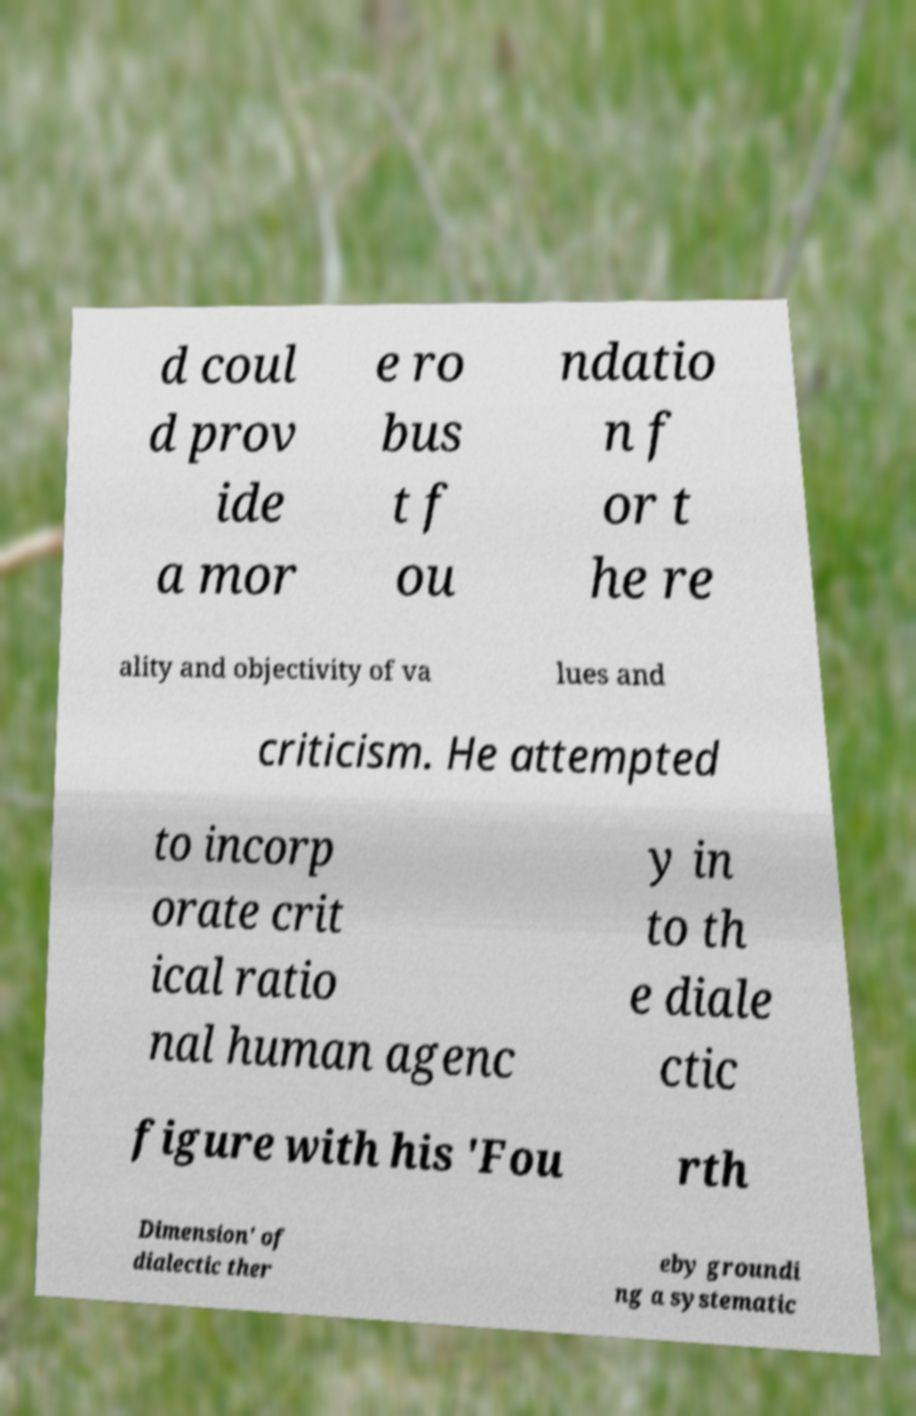Can you read and provide the text displayed in the image?This photo seems to have some interesting text. Can you extract and type it out for me? d coul d prov ide a mor e ro bus t f ou ndatio n f or t he re ality and objectivity of va lues and criticism. He attempted to incorp orate crit ical ratio nal human agenc y in to th e diale ctic figure with his 'Fou rth Dimension' of dialectic ther eby groundi ng a systematic 